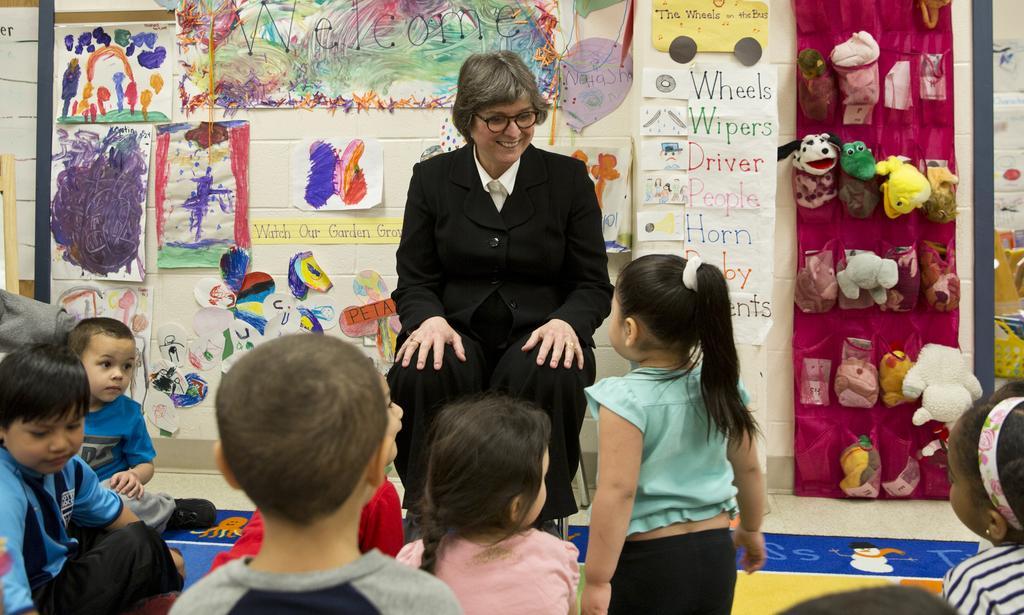Could you give a brief overview of what you see in this image? In this image we can see a woman is sitting on the chair. At the bottom of the image, we can see children. In the background, we can see so many papers and toys on the wall. 